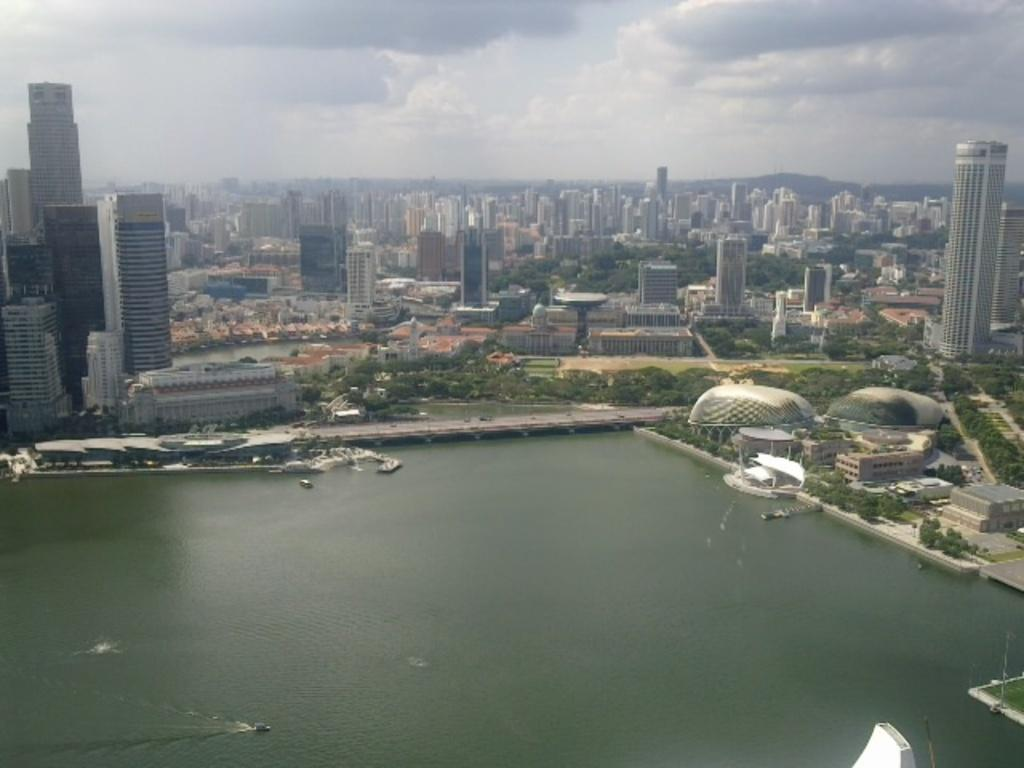What type of structures can be seen in the image? There are buildings in the image. What other natural elements are present in the image? There are trees in the image. What can be seen on the water in the image? There are boats on the water in the image. What type of transportation is visible on the roads in the image? There are vehicles on roads in the image. What is visible in the background of the image? The sky is visible in the background of the image. Where is the bottle located in the image? There is no bottle present in the image. What type of bun is being used as a decoration in the image? There is no bun present in the image. 